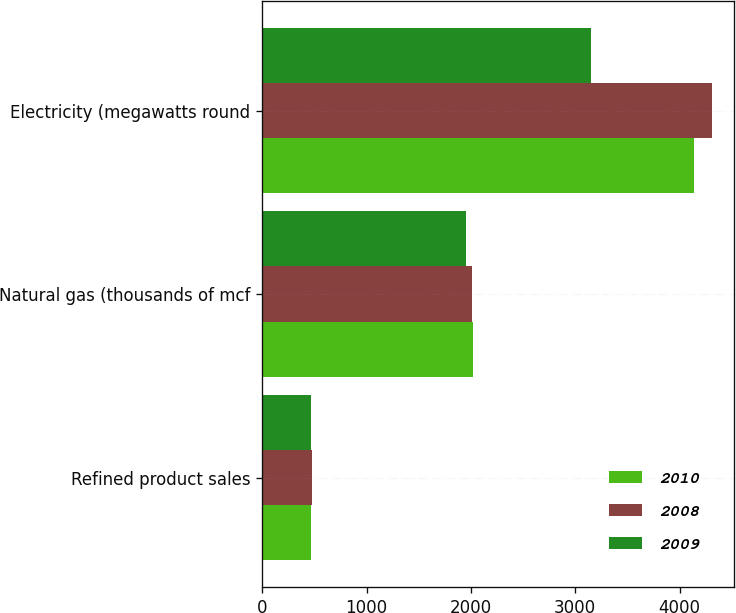Convert chart to OTSL. <chart><loc_0><loc_0><loc_500><loc_500><stacked_bar_chart><ecel><fcel>Refined product sales<fcel>Natural gas (thousands of mcf<fcel>Electricity (megawatts round<nl><fcel>2010<fcel>471<fcel>2016<fcel>4140<nl><fcel>2008<fcel>473<fcel>2010<fcel>4306<nl><fcel>2009<fcel>472<fcel>1955<fcel>3152<nl></chart> 